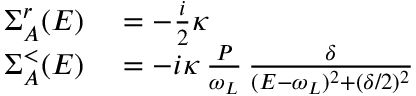<formula> <loc_0><loc_0><loc_500><loc_500>\begin{array} { r l } { \Sigma _ { A } ^ { r } ( E ) } & = - \frac { i } { 2 } \kappa } \\ { \Sigma _ { A } ^ { < } ( E ) } & = - i \kappa \, \frac { P } { \omega _ { L } } \, \frac { \delta } { ( E - \omega _ { L } ) ^ { 2 } + ( \delta / 2 ) ^ { 2 } } } \end{array}</formula> 